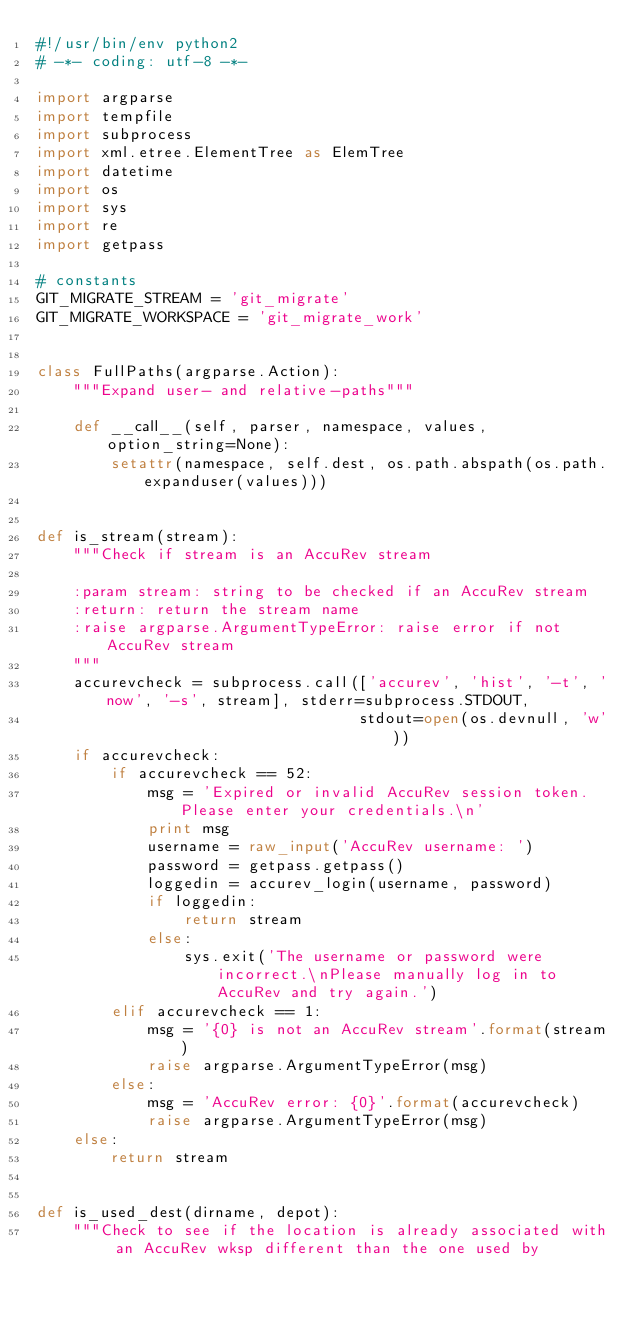Convert code to text. <code><loc_0><loc_0><loc_500><loc_500><_Python_>#!/usr/bin/env python2
# -*- coding: utf-8 -*-

import argparse
import tempfile
import subprocess
import xml.etree.ElementTree as ElemTree
import datetime
import os
import sys
import re
import getpass

# constants
GIT_MIGRATE_STREAM = 'git_migrate'
GIT_MIGRATE_WORKSPACE = 'git_migrate_work'


class FullPaths(argparse.Action):
    """Expand user- and relative-paths"""

    def __call__(self, parser, namespace, values, option_string=None):
        setattr(namespace, self.dest, os.path.abspath(os.path.expanduser(values)))


def is_stream(stream):
    """Check if stream is an AccuRev stream

    :param stream: string to be checked if an AccuRev stream
    :return: return the stream name
    :raise argparse.ArgumentTypeError: raise error if not AccuRev stream
    """
    accurevcheck = subprocess.call(['accurev', 'hist', '-t', 'now', '-s', stream], stderr=subprocess.STDOUT,
                                   stdout=open(os.devnull, 'w'))
    if accurevcheck:
        if accurevcheck == 52:
            msg = 'Expired or invalid AccuRev session token. Please enter your credentials.\n'
            print msg
            username = raw_input('AccuRev username: ')
            password = getpass.getpass()
            loggedin = accurev_login(username, password)
            if loggedin:
                return stream
            else:
                sys.exit('The username or password were incorrect.\nPlease manually log in to AccuRev and try again.')
        elif accurevcheck == 1:
            msg = '{0} is not an AccuRev stream'.format(stream)
            raise argparse.ArgumentTypeError(msg)
        else:
            msg = 'AccuRev error: {0}'.format(accurevcheck)
            raise argparse.ArgumentTypeError(msg)
    else:
        return stream


def is_used_dest(dirname, depot):
    """Check to see if the location is already associated with an AccuRev wksp different than the one used by</code> 